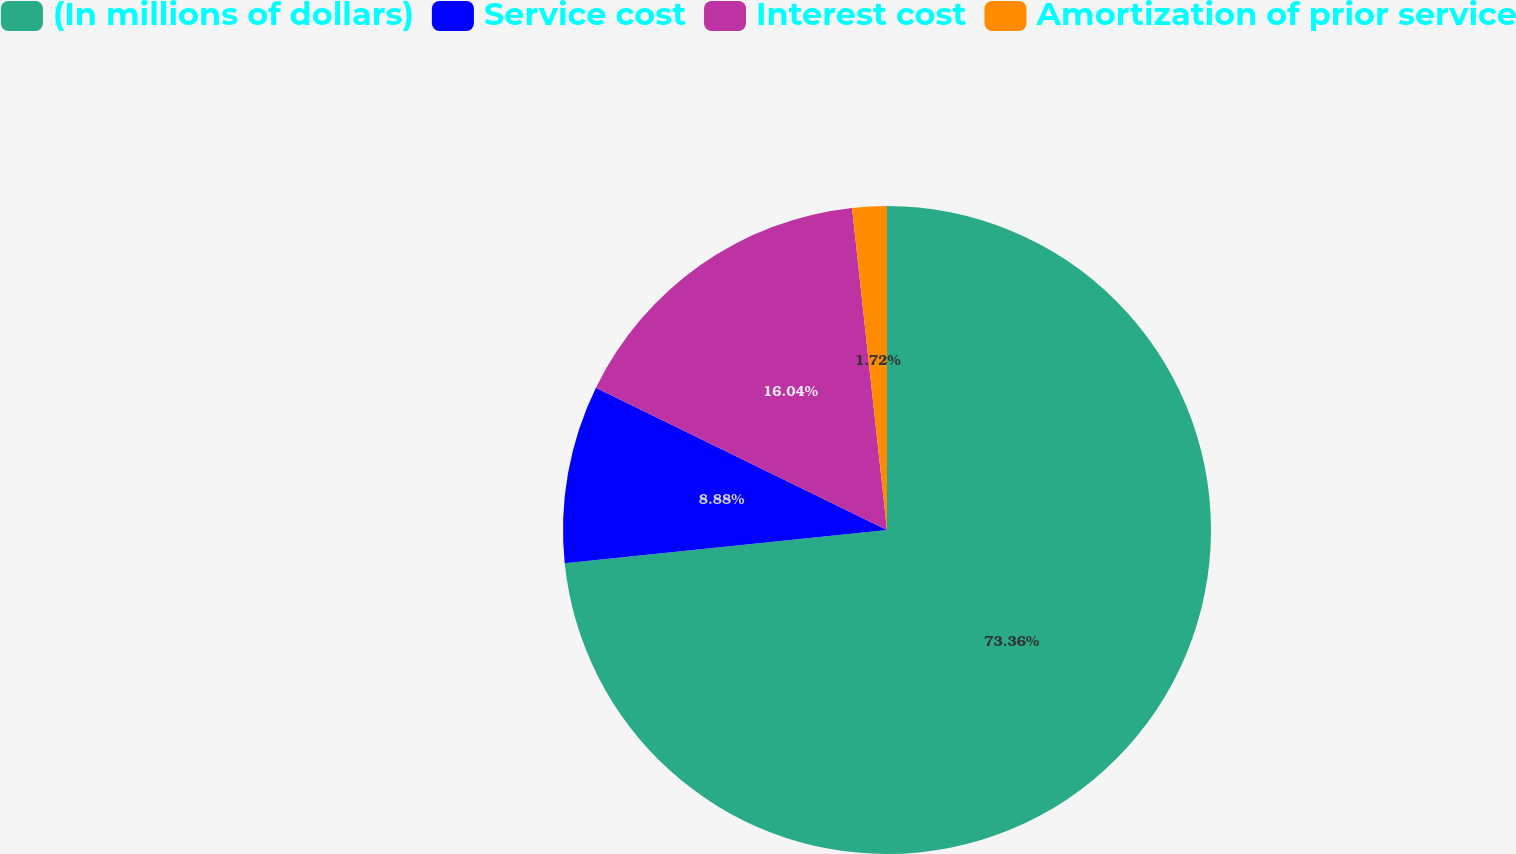Convert chart. <chart><loc_0><loc_0><loc_500><loc_500><pie_chart><fcel>(In millions of dollars)<fcel>Service cost<fcel>Interest cost<fcel>Amortization of prior service<nl><fcel>73.36%<fcel>8.88%<fcel>16.04%<fcel>1.72%<nl></chart> 